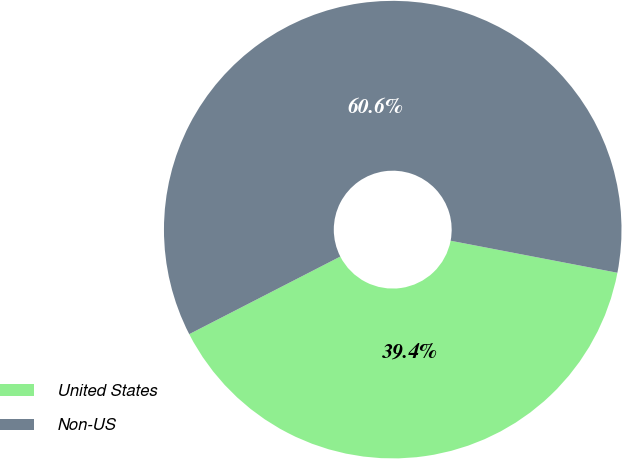<chart> <loc_0><loc_0><loc_500><loc_500><pie_chart><fcel>United States<fcel>Non-US<nl><fcel>39.43%<fcel>60.57%<nl></chart> 